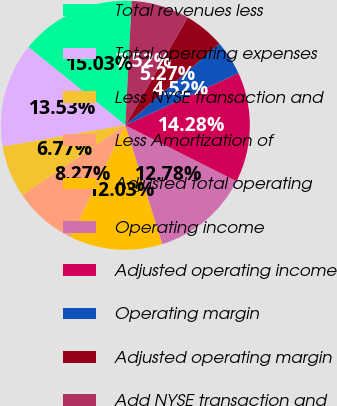Convert chart. <chart><loc_0><loc_0><loc_500><loc_500><pie_chart><fcel>Total revenues less<fcel>Total operating expenses<fcel>Less NYSE transaction and<fcel>Less Amortization of<fcel>Adjusted total operating<fcel>Operating income<fcel>Adjusted operating income<fcel>Operating margin<fcel>Adjusted operating margin<fcel>Add NYSE transaction and<nl><fcel>15.03%<fcel>13.53%<fcel>6.77%<fcel>8.27%<fcel>12.03%<fcel>12.78%<fcel>14.28%<fcel>4.52%<fcel>5.27%<fcel>7.52%<nl></chart> 